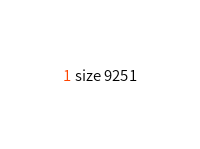<code> <loc_0><loc_0><loc_500><loc_500><_YAML_>size 9251
</code> 